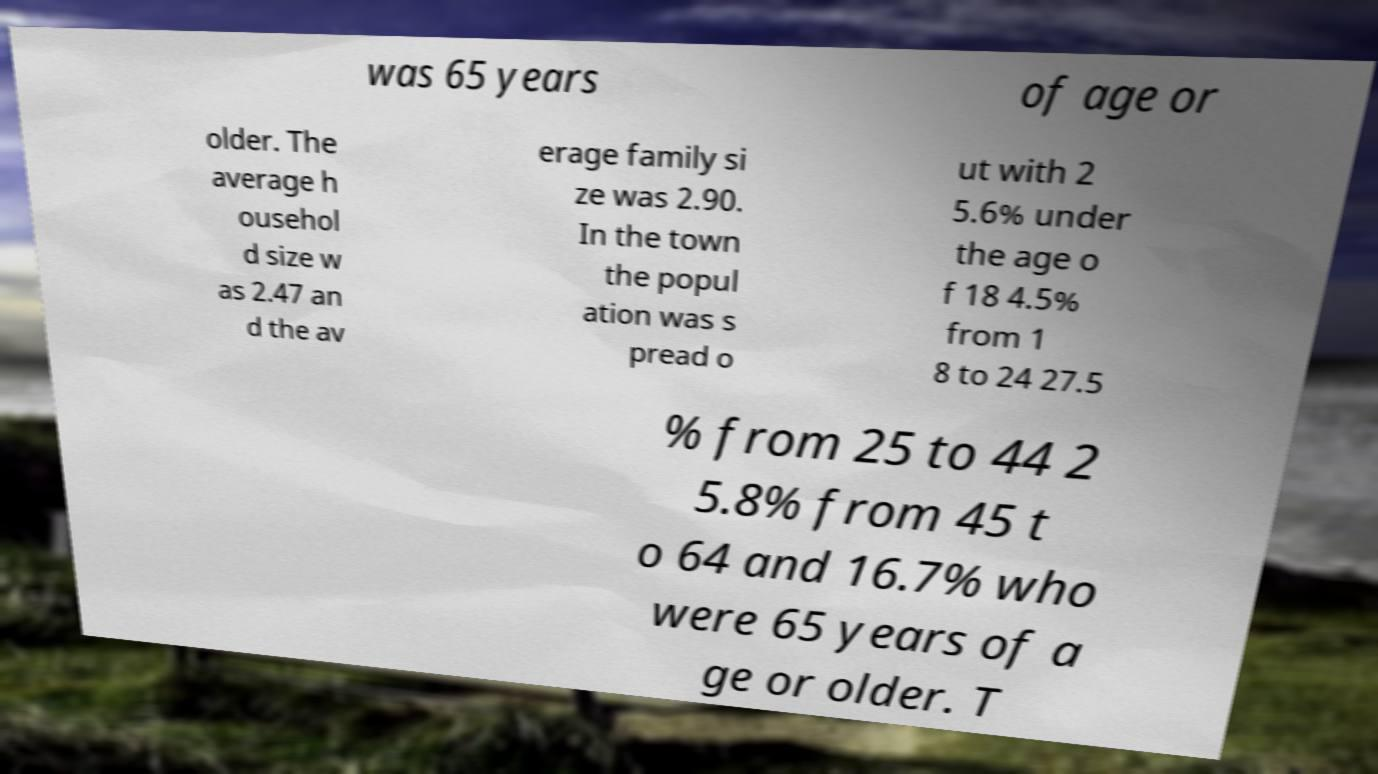Can you read and provide the text displayed in the image?This photo seems to have some interesting text. Can you extract and type it out for me? was 65 years of age or older. The average h ousehol d size w as 2.47 an d the av erage family si ze was 2.90. In the town the popul ation was s pread o ut with 2 5.6% under the age o f 18 4.5% from 1 8 to 24 27.5 % from 25 to 44 2 5.8% from 45 t o 64 and 16.7% who were 65 years of a ge or older. T 